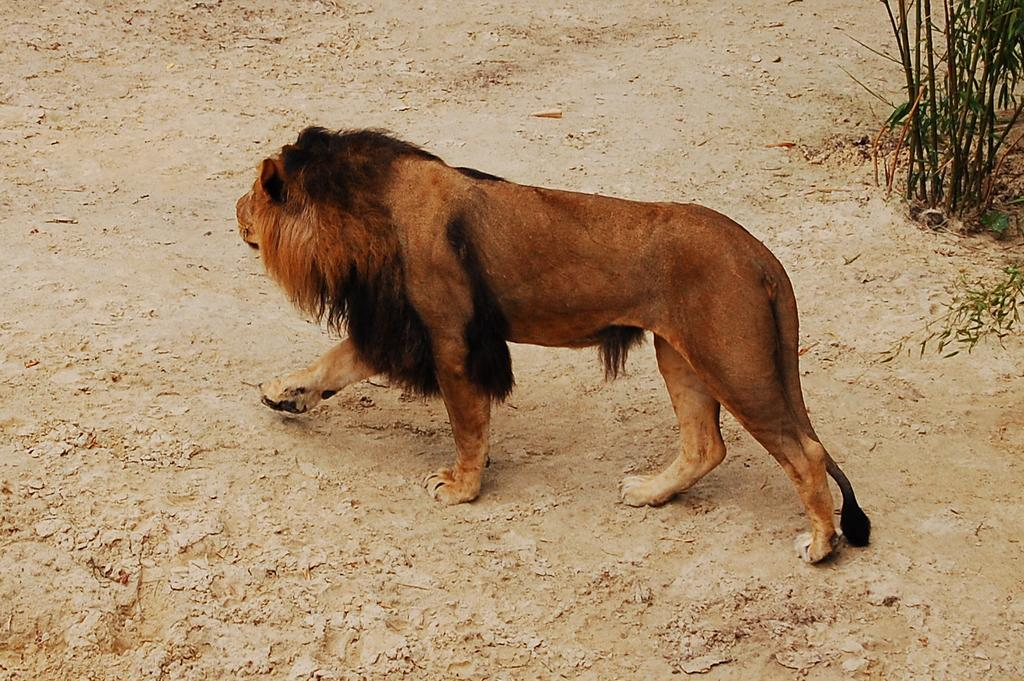What animal is in the foreground of the image? There is a lion in the foreground of the image. What is the lion doing in the image? The lion is walking on the ground. What can be seen on the right top side of the image? There are plants on the right top side of the image. What type of weather can be seen in the image? The provided facts do not mention any weather conditions, so it cannot be determined from the image. 